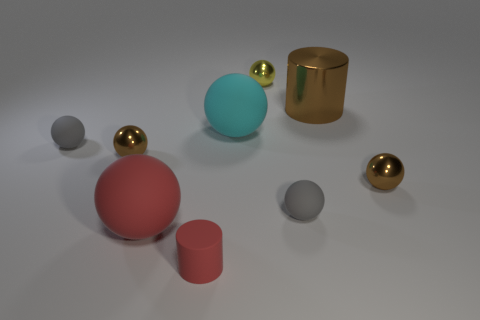Subtract all gray spheres. How many spheres are left? 5 Subtract all red rubber spheres. How many spheres are left? 6 Subtract all red balls. Subtract all gray cylinders. How many balls are left? 6 Add 1 large purple rubber things. How many objects exist? 10 Subtract all cylinders. How many objects are left? 7 Subtract all gray balls. Subtract all small shiny balls. How many objects are left? 4 Add 4 matte things. How many matte things are left? 9 Add 5 small purple metal cylinders. How many small purple metal cylinders exist? 5 Subtract 0 cyan cubes. How many objects are left? 9 